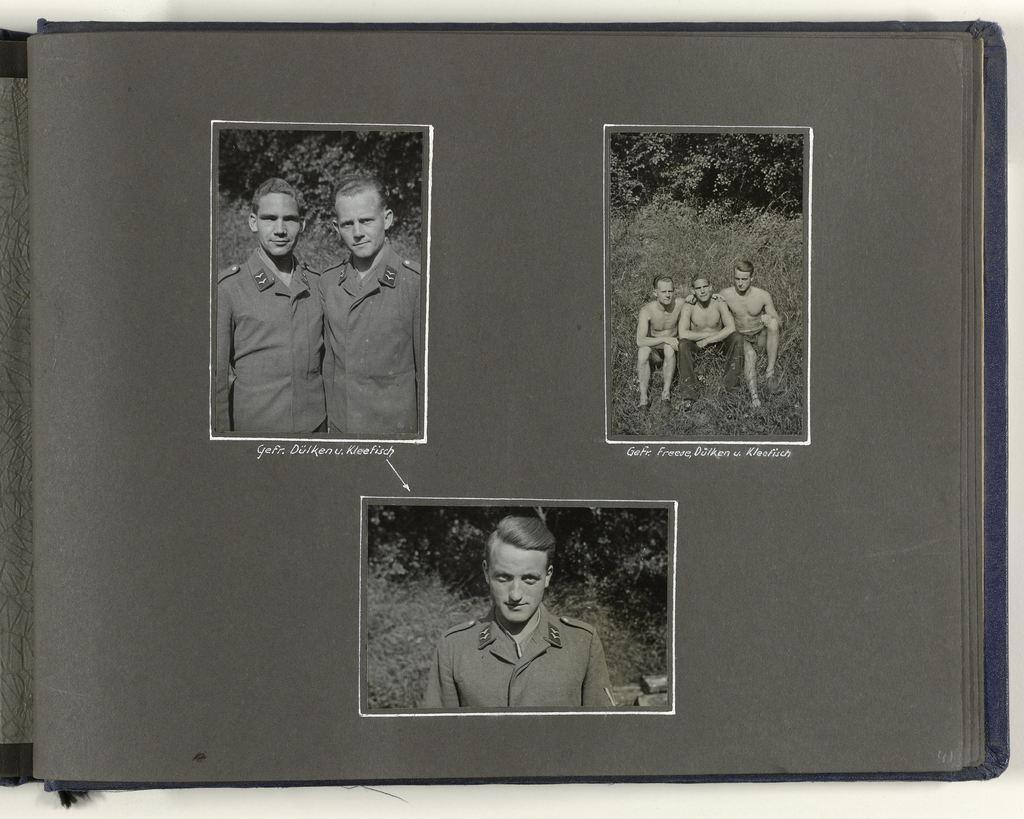Describe this image in one or two sentences. In this image we can see the cover page of a book on which there are some pictures of some persons. 